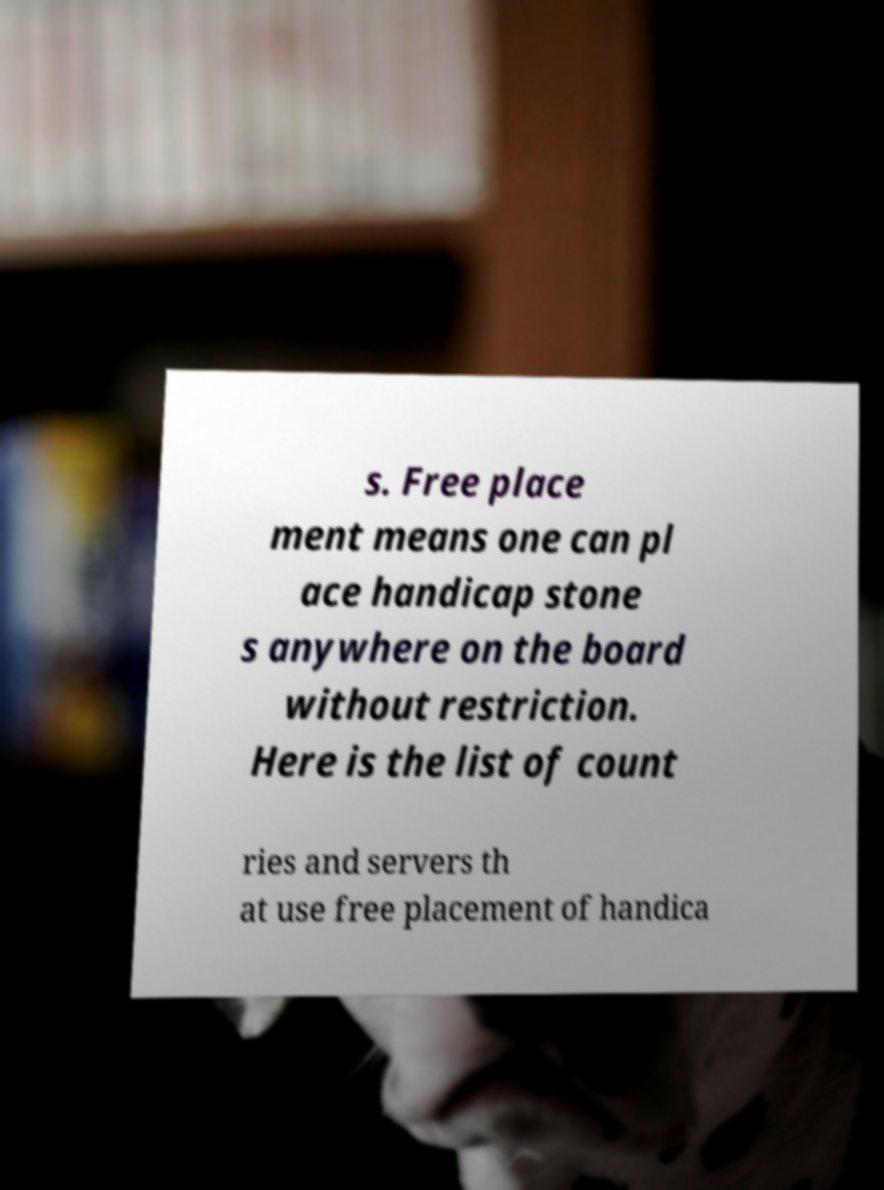Please identify and transcribe the text found in this image. s. Free place ment means one can pl ace handicap stone s anywhere on the board without restriction. Here is the list of count ries and servers th at use free placement of handica 